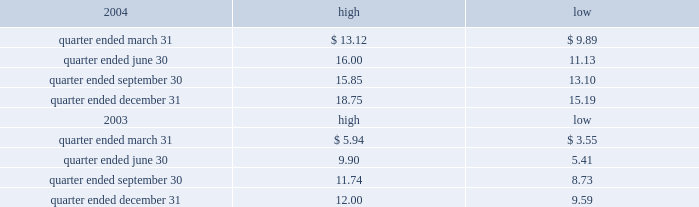Part ii item 5 .
Market for registrant 2019s common equity , related stockholder matters and issuer purchases of equity securities the table presents reported quarterly high and low per share sale prices of our class a common stock on the new york stock exchange ( nyse ) for the years 2004 and 2003. .
On march 18 , 2005 , the closing price of our class a common stock was $ 18.79 per share as reported on the as of march 18 , 2005 , we had 230604932 outstanding shares of class a common stock and 743 registered holders .
In february 2004 , all outstanding shares of our class b common stock were converted into shares of our class a common stock on a one-for-one basis pursuant to the occurrence of the 201cdodge conversion event 201d as defined in our charter .
Our charter prohibits the future issuance of shares of class b common stock .
Also in february 2004 , all outstanding shares of class c common stock were converted into shares of class a common stock on a one-for-one basis .
Our charter permits the issuance of shares of class c common stock in the future .
The information under 201csecurities authorized for issuance under equity compensation plans 201d from the definitive proxy statement is hereby incorporated by reference into item 12 of this annual report .
Dividends we have never paid a dividend on any class of common stock .
We anticipate that we may retain future earnings , if any , to fund the development and growth of our business .
The indentures governing our 93 20448% ( 20448 % ) senior notes due 2009 , our 7.50% ( 7.50 % ) senior notes due 2012 , and our 7.125% ( 7.125 % ) senior notes due 2012 prohibit us from paying dividends to our stockholders unless we satisfy certain financial covenants .
Our borrower subsidiaries are generally prohibited under the terms of the credit facility , subject to certain exceptions , from making to us any direct or indirect distribution , dividend or other payment on account of their limited liability company interests , partnership interests , capital stock or other equity interests , except that , if no default exists or would be created thereby under the credit facility , our borrower subsidiaries may pay cash dividends or make other distributions to us in accordance with the credit facility within certain specified amounts and , in addition , may pay cash dividends or make other distributions to us in respect of our outstanding indebtedness and permitted future indebtedness .
The indentures governing the 12.25% ( 12.25 % ) senior subordinated discount notes due 2008 and the 7.25% ( 7.25 % ) senior subordinated notes due 2011 of american towers , inc .
( ati ) , our principal operating subsidiary , prohibit ati and certain of our other subsidiaries that have guaranteed those notes ( sister guarantors ) from paying dividends and making other payments or distributions to us unless certain .
What is the average number of shares per registered holder as of march 18 , 2005? 
Computations: (230604932 / 743)
Answer: 310370.02961. 